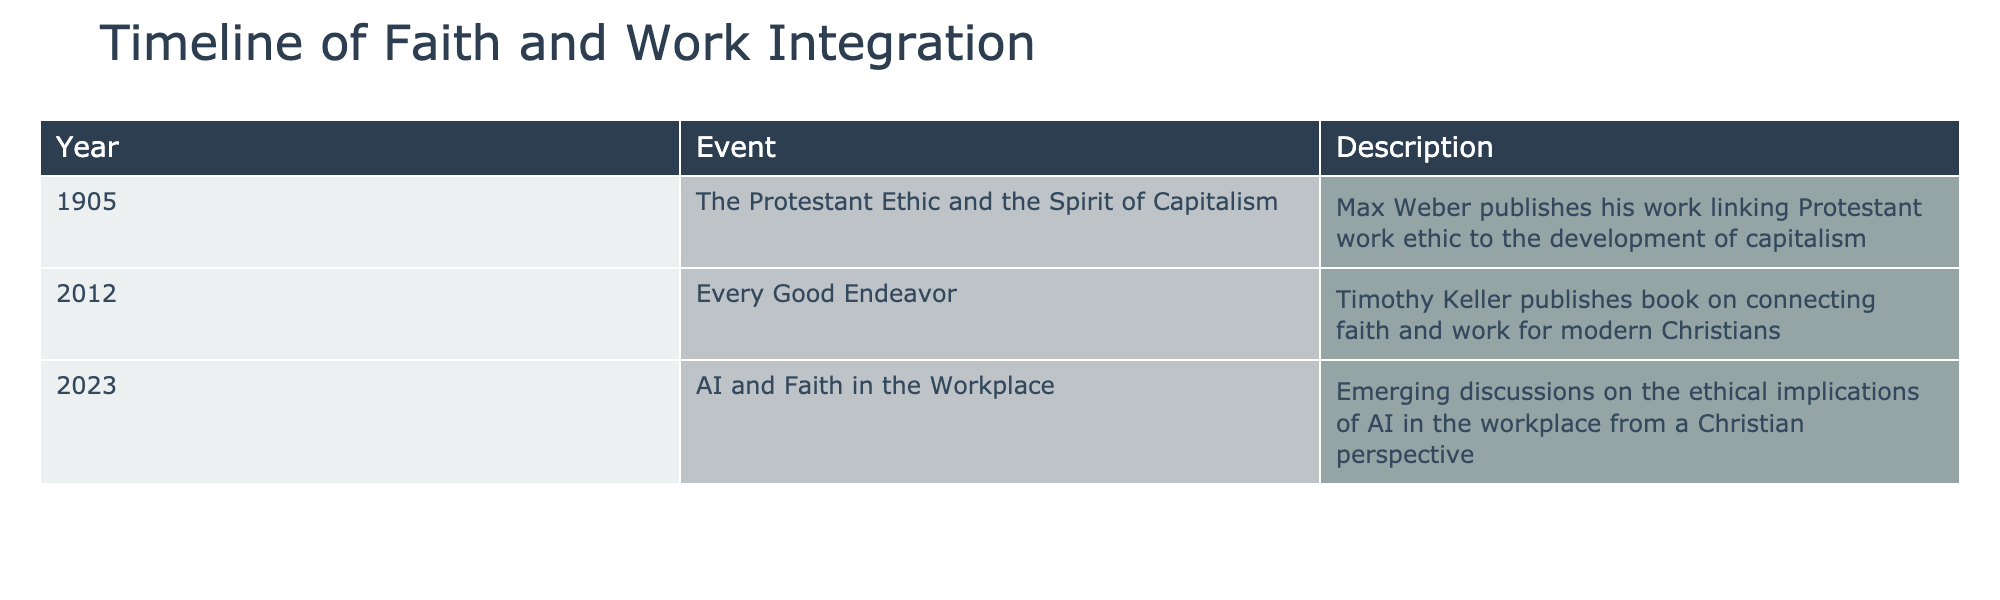What year did Max Weber publish "The Protestant Ethic and the Spirit of Capitalism"? The table states that the event occurred in the year 1905. Therefore, Max Weber published his work in 1905.
Answer: 1905 How many significant events related to faith and work are listed in the timeline? The table lists three significant events: one in 1905, one in 2012, and one in 2023. Upon counting them, we find that there are a total of three events.
Answer: 3 Is "Every Good Endeavor" published before or after 2010? Referring to the table, "Every Good Endeavor" was published in 2012, which is after 2010. Therefore, it is published after 2010.
Answer: After What is the range of years covered by the events listed in the timeline? The first event is from 1905 and the last event is from 2023. To find the range, subtract the earlier year from the later year: 2023 - 1905 = 118. Thus, the range of years is 118 years.
Answer: 118 years Did discussions about AI in the workplace occur before 2023? According to the table, the event concerning AI and faith in the workplace occurred in 2023. Since it is the latest event listed, there are no discussions about AI before this year mentioned in the table.
Answer: No Considering all events, how many years apart is "The Protestant Ethic and the Spirit of Capitalism" and "Every Good Endeavor"? The first event occurred in 1905 and the second in 2012. To find the difference in years, we subtract: 2012 - 1905 = 107 years. Therefore, these events are 107 years apart.
Answer: 107 years Was the event related to AI in the workplace the first on the list? The event regarding AI and faith in the workplace is listed for the year 2023, which is not the first on the list. The first event is dated 1905. Therefore, the AI-related event is not the first on the list.
Answer: No Which event represents a contemporary discussion related to faith and work? The 2023 event regarding "AI and Faith in the Workplace" signifies contemporary discussions relevant to modern issues faced by Christians in the workplace according to the table.
Answer: 2023 event 